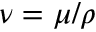Convert formula to latex. <formula><loc_0><loc_0><loc_500><loc_500>\nu = \mu / \rho</formula> 